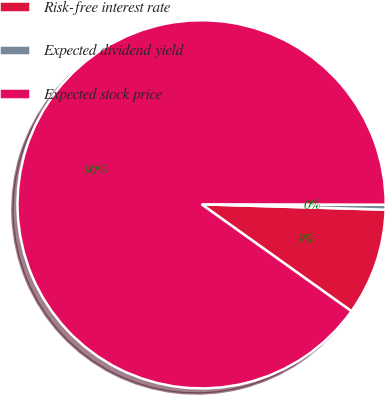Convert chart. <chart><loc_0><loc_0><loc_500><loc_500><pie_chart><fcel>Risk-free interest rate<fcel>Expected dividend yield<fcel>Expected stock price<nl><fcel>9.4%<fcel>0.43%<fcel>90.16%<nl></chart> 